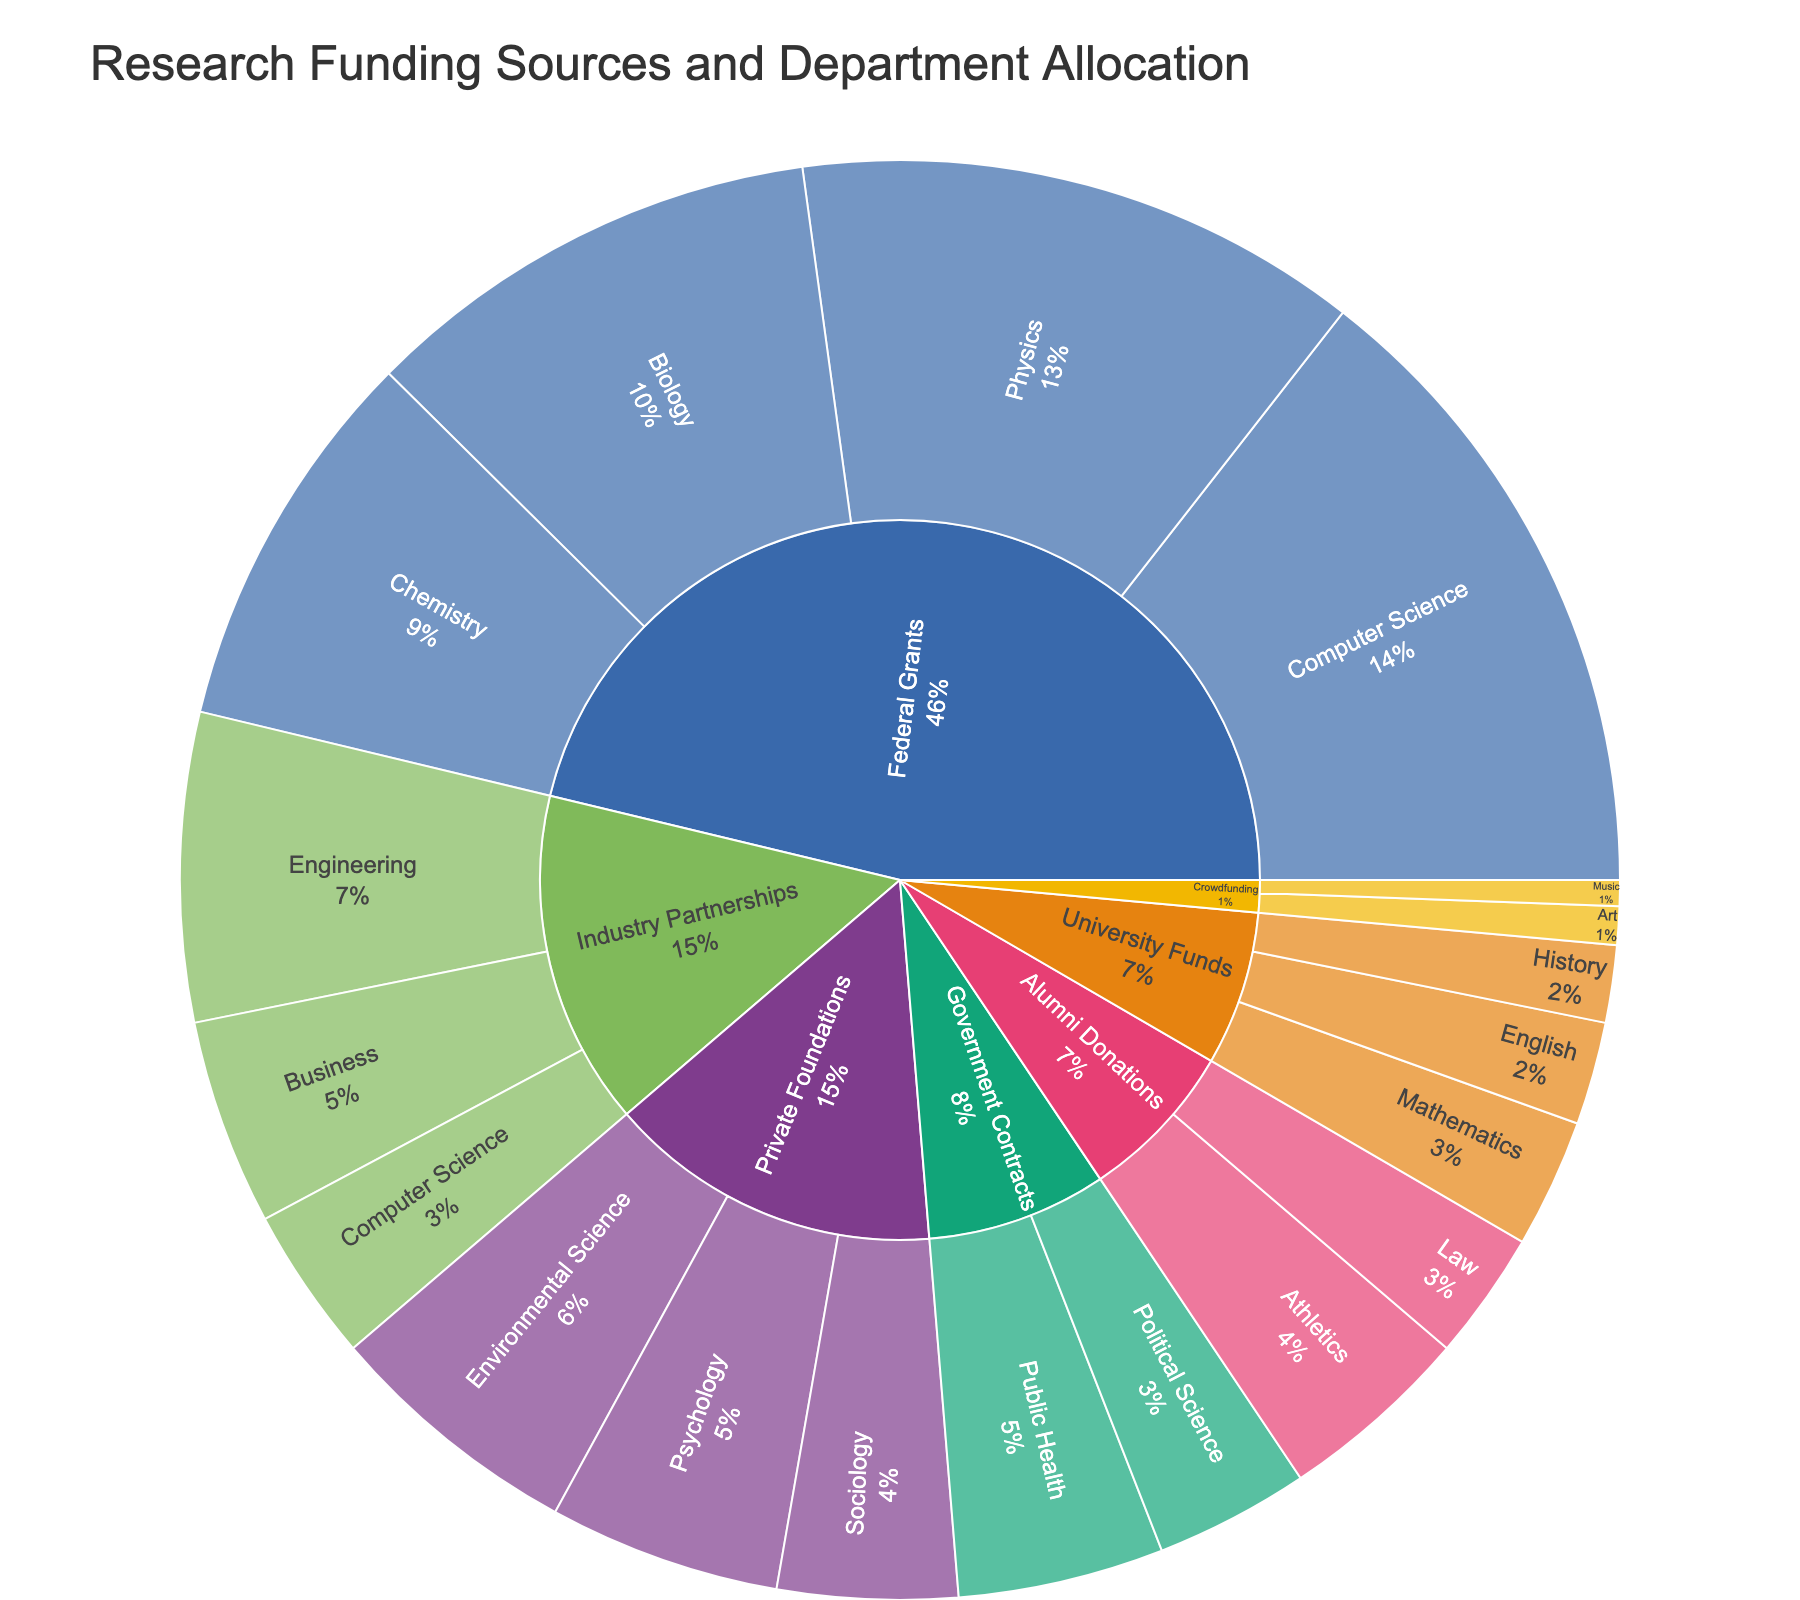What is the title of the sunburst plot? The title of a plot usually appears at the top and serves as a brief description of its contents. In this case, it is clearly visible as "Research Funding Sources and Department Allocation."
Answer: Research Funding Sources and Department Allocation Which funding source has the highest total allocation? By assessing the segments' size under each funding source in the plot, Federal Grants encompasses the largest area, signifying the highest allocation among all funding sources.
Answer: Federal Grants How much funding does the Biology department receive from Federal Grants? Hovering over the Biology segment under Federal Grants in the plot reveals that the allocation is $1,800,000.
Answer: $1,800,000 Which department received the least funding, and from what source? By identifying the smallest segment in the sunburst plot, we see that the Music department, funded by Crowdfunding, received the least allocation of $100,000.
Answer: Music, Crowdfunding What is the total allocation of funding from Private Foundations? Summing up the allocations of all departments funded by Private Foundations (Psychology, Sociology, and Environmental Science): $900,000 + $700,000 + $1,000,000 = $2,600,000.
Answer: $2,600,000 Compare the allocations between the Computer Science department and the Art department. Which one received more funding, and by how much? The Computer Science department, receiving $2,500,000 from Federal Grants and $600,000 from Industry Partnerships, totals $3,100,000. The Art department received $150,000 from Crowdfunding. Therefore, Computer Science received $3,100,000 - $150,000 = $2,950,000 more.
Answer: Computer Science, $2,950,000 How does the funding allocation for Engineering compare with that for Business from Industry Partnerships? The plot shows that Engineering received $1,200,000 whereas Business received $800,000. Hence, Engineering got $400,000 more.
Answer: Engineering, $400,000 What percentage of University Funds is allocated to Mathematics? The Mathematics department received $500,000 from University Funds. To find the percentage, divide the Mathematics allocation by the total University Funds allocations: ($500,000 / ($500,000 + $400,000 + $300,000)) * 100 = 41.67%.
Answer: 41.67% Identify the department funded by Government Contracts with the higher allocation and specify its value. The sunburst plot shows that Public Health received $800,000, higher than Political Science's $600,000 under Government Contracts.
Answer: Public Health, $800,000 